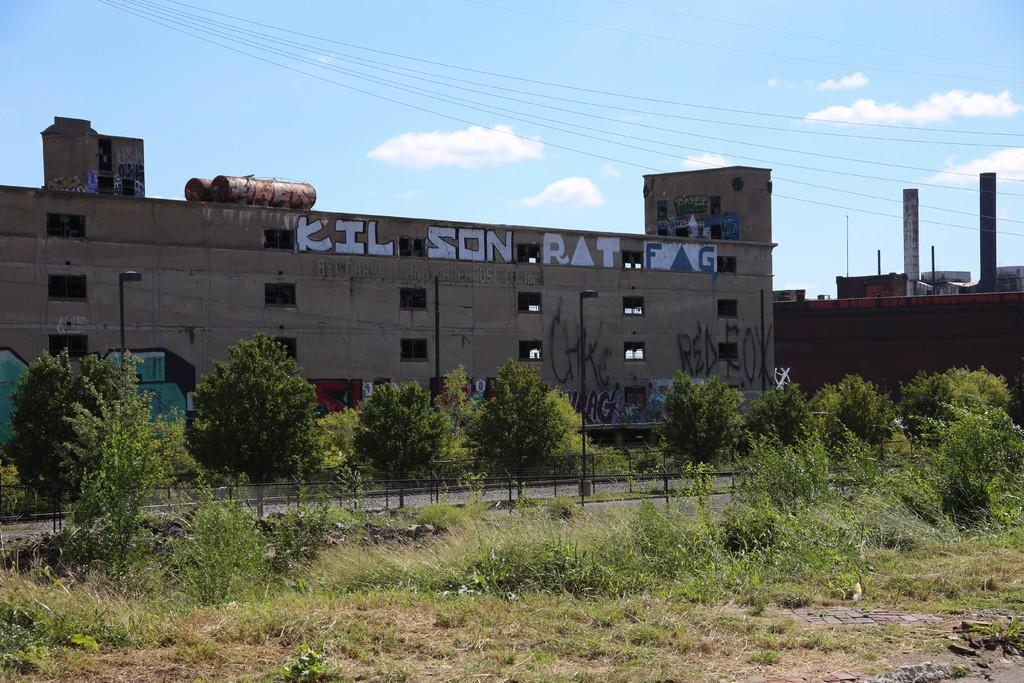What can be seen in the sky in the image? The sky with clouds is visible in the image. What infrastructure elements are present in the image? Electric cables, buildings, poles, and a fence are present in the image. What type of vegetation can be seen in the image? Trees, bushes, and grass are visible in the image. How many planes are flying in the sky in the image? There are no planes visible in the sky in the image. Who is the expert responsible for designing the buildings in the image? The facts provided do not mention any specific expert responsible for designing the buildings in the image. 